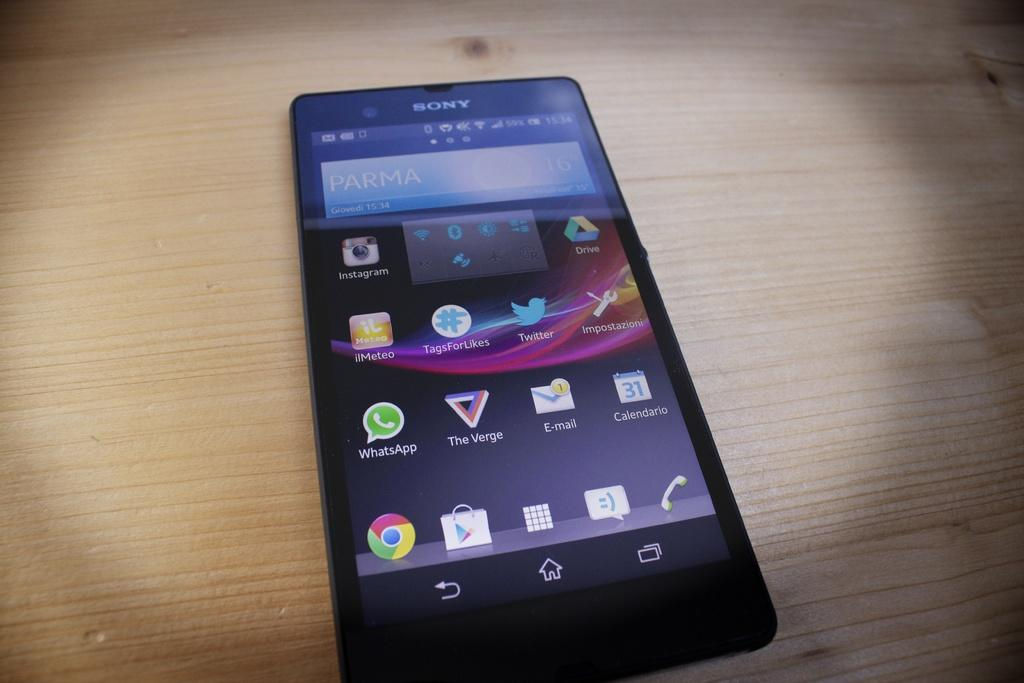<image>
Describe the image concisely. A black Sony brand cellphone with the app Parma open on the top of the screen 